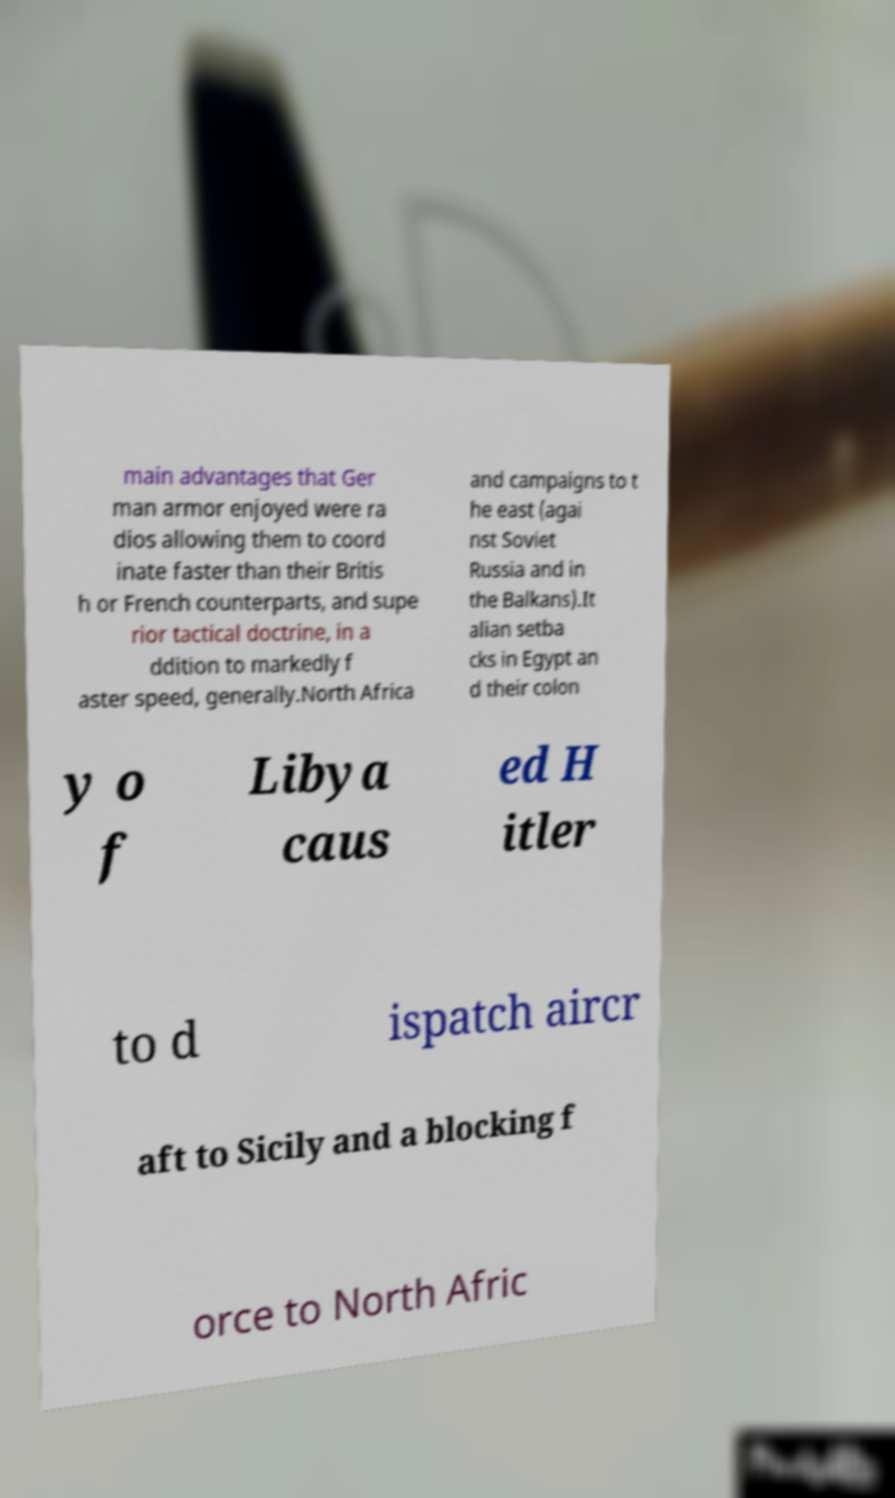Could you assist in decoding the text presented in this image and type it out clearly? main advantages that Ger man armor enjoyed were ra dios allowing them to coord inate faster than their Britis h or French counterparts, and supe rior tactical doctrine, in a ddition to markedly f aster speed, generally.North Africa and campaigns to t he east (agai nst Soviet Russia and in the Balkans).It alian setba cks in Egypt an d their colon y o f Libya caus ed H itler to d ispatch aircr aft to Sicily and a blocking f orce to North Afric 